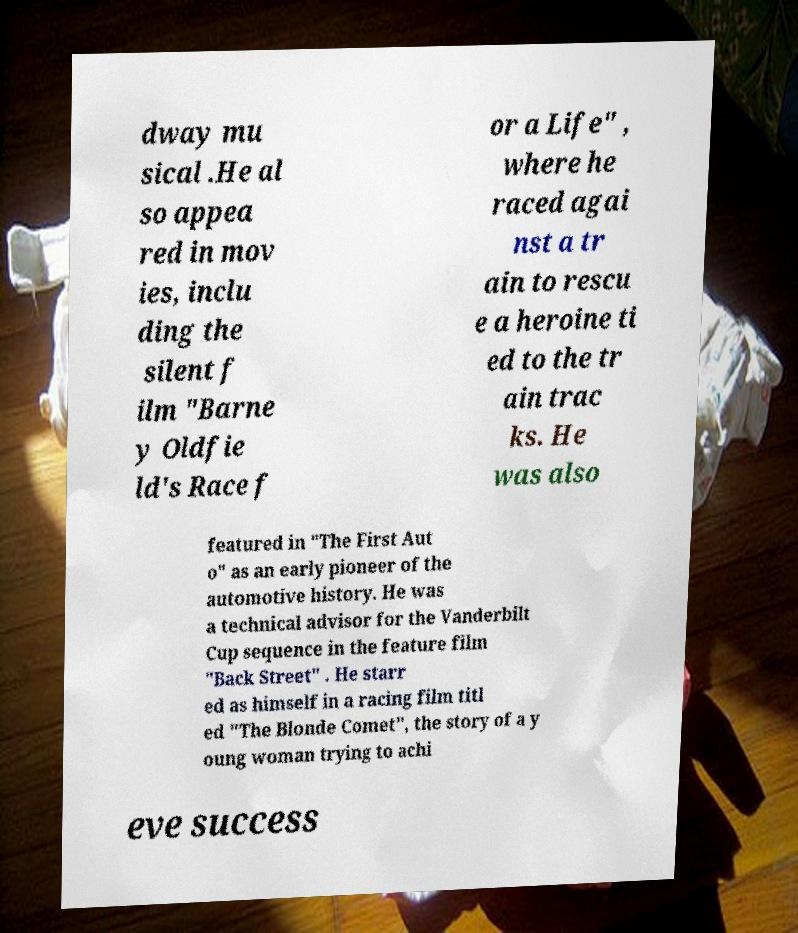There's text embedded in this image that I need extracted. Can you transcribe it verbatim? dway mu sical .He al so appea red in mov ies, inclu ding the silent f ilm "Barne y Oldfie ld's Race f or a Life" , where he raced agai nst a tr ain to rescu e a heroine ti ed to the tr ain trac ks. He was also featured in "The First Aut o" as an early pioneer of the automotive history. He was a technical advisor for the Vanderbilt Cup sequence in the feature film "Back Street" . He starr ed as himself in a racing film titl ed "The Blonde Comet", the story of a y oung woman trying to achi eve success 